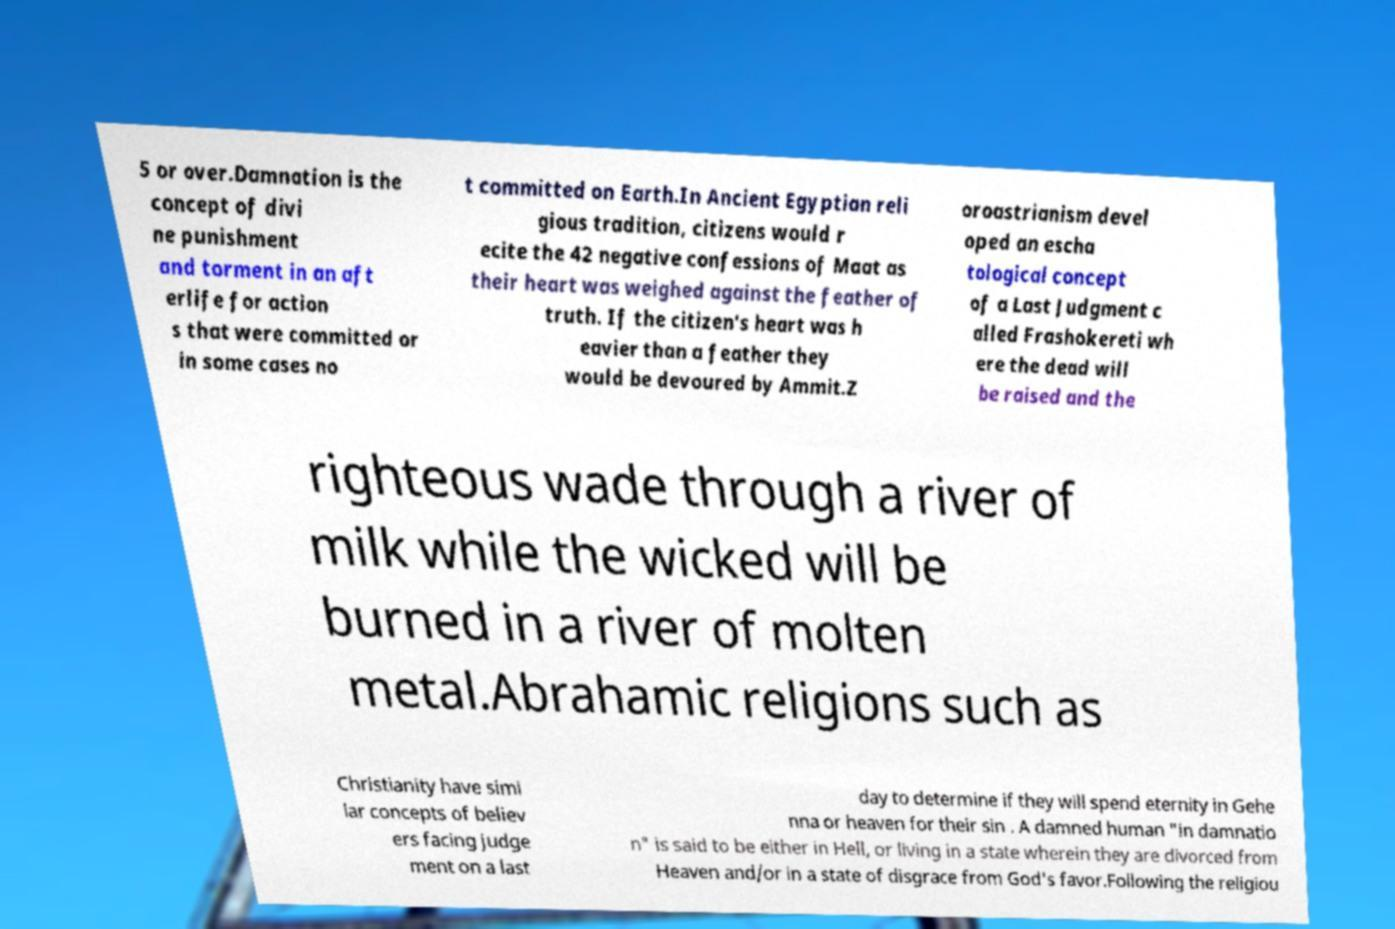Please identify and transcribe the text found in this image. 5 or over.Damnation is the concept of divi ne punishment and torment in an aft erlife for action s that were committed or in some cases no t committed on Earth.In Ancient Egyptian reli gious tradition, citizens would r ecite the 42 negative confessions of Maat as their heart was weighed against the feather of truth. If the citizen's heart was h eavier than a feather they would be devoured by Ammit.Z oroastrianism devel oped an escha tological concept of a Last Judgment c alled Frashokereti wh ere the dead will be raised and the righteous wade through a river of milk while the wicked will be burned in a river of molten metal.Abrahamic religions such as Christianity have simi lar concepts of believ ers facing judge ment on a last day to determine if they will spend eternity in Gehe nna or heaven for their sin . A damned human "in damnatio n" is said to be either in Hell, or living in a state wherein they are divorced from Heaven and/or in a state of disgrace from God's favor.Following the religiou 